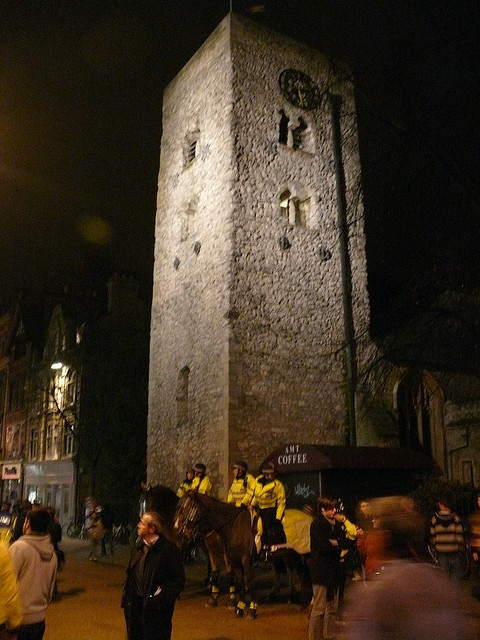Describe the objects in this image and their specific colors. I can see people in black, maroon, brown, and salmon tones, horse in black, olive, and maroon tones, people in black, brown, and maroon tones, people in black, maroon, and brown tones, and people in black, maroon, and brown tones in this image. 